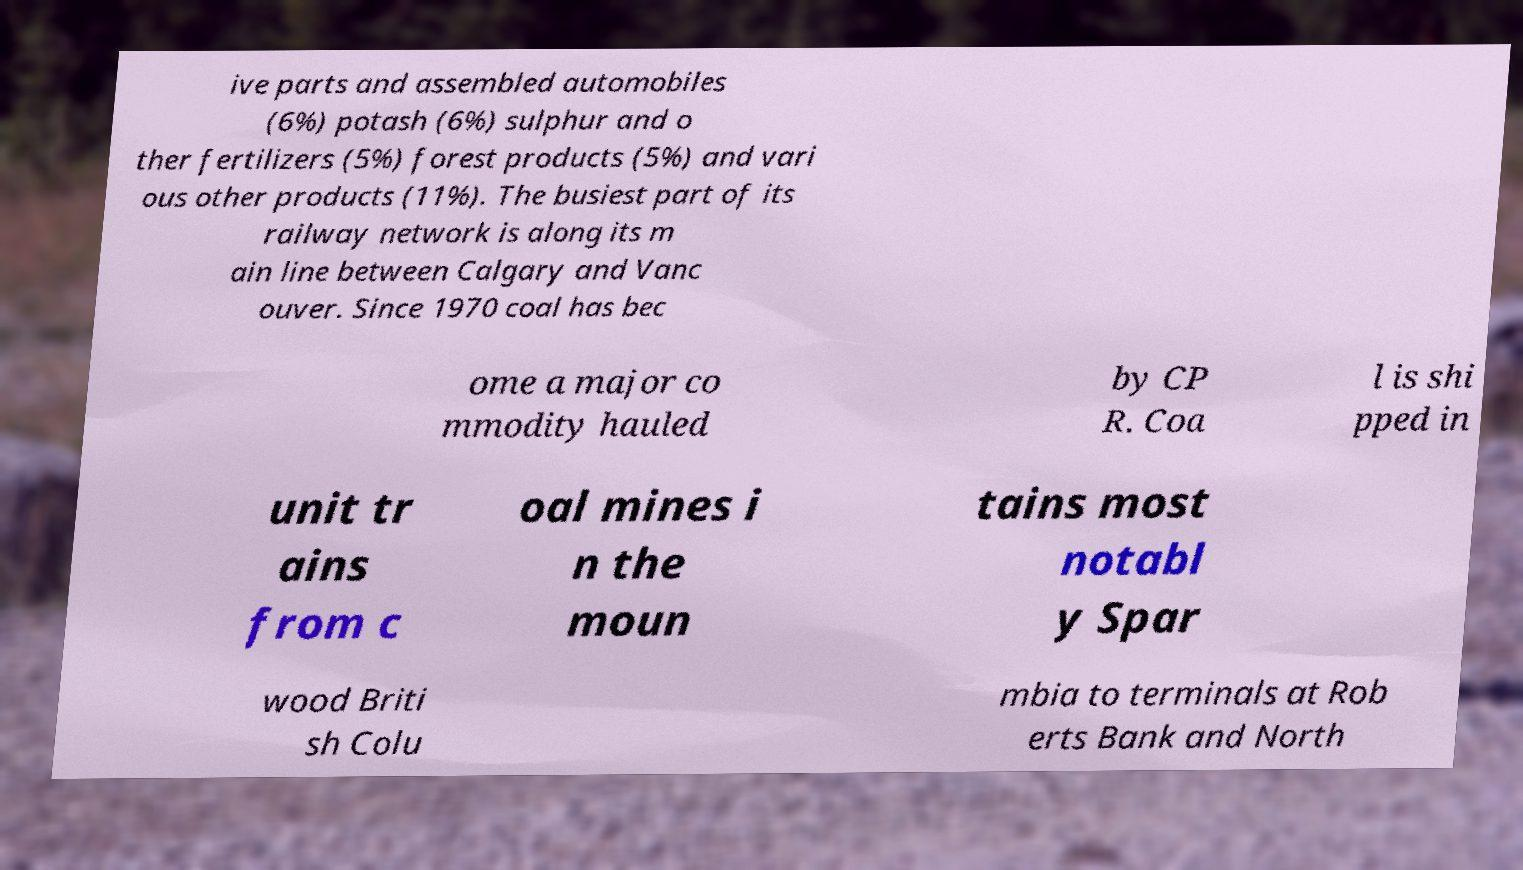Please read and relay the text visible in this image. What does it say? ive parts and assembled automobiles (6%) potash (6%) sulphur and o ther fertilizers (5%) forest products (5%) and vari ous other products (11%). The busiest part of its railway network is along its m ain line between Calgary and Vanc ouver. Since 1970 coal has bec ome a major co mmodity hauled by CP R. Coa l is shi pped in unit tr ains from c oal mines i n the moun tains most notabl y Spar wood Briti sh Colu mbia to terminals at Rob erts Bank and North 